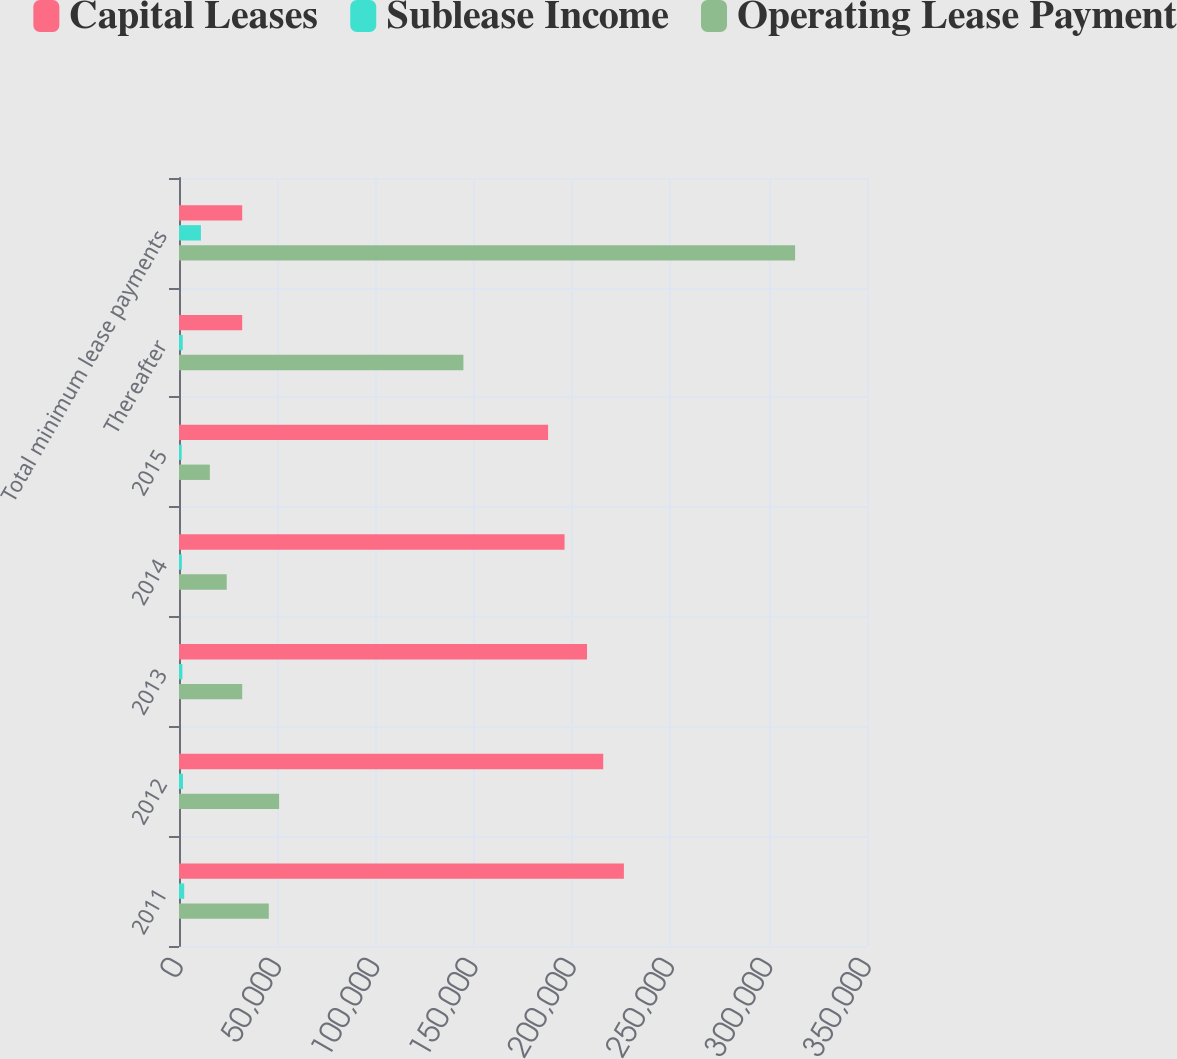<chart> <loc_0><loc_0><loc_500><loc_500><stacked_bar_chart><ecel><fcel>2011<fcel>2012<fcel>2013<fcel>2014<fcel>2015<fcel>Thereafter<fcel>Total minimum lease payments<nl><fcel>Capital Leases<fcel>226320<fcel>215812<fcel>207556<fcel>196141<fcel>187767<fcel>32151<fcel>32151<nl><fcel>Sublease Income<fcel>2649<fcel>2042<fcel>1726<fcel>1468<fcel>1376<fcel>1899<fcel>11160<nl><fcel>Operating Lease Payment<fcel>45686<fcel>50927<fcel>32151<fcel>24281<fcel>15694<fcel>144685<fcel>313424<nl></chart> 